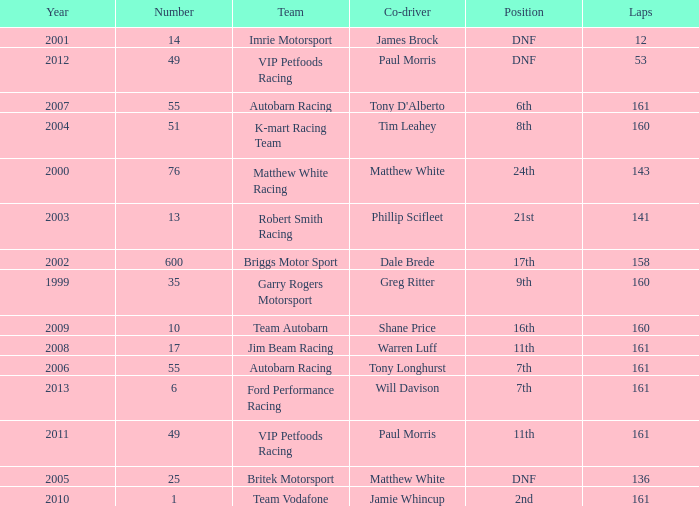What is the fewest laps for a team with a position of DNF and a number smaller than 25 before 2001? None. 